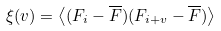Convert formula to latex. <formula><loc_0><loc_0><loc_500><loc_500>\xi ( v ) = \left < ( F _ { i } - \overline { F } ) ( F _ { i + v } - \overline { F } ) \right ></formula> 